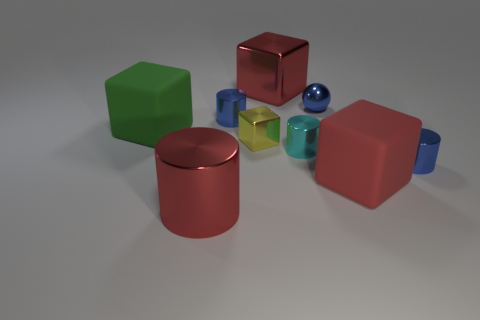The green block is what size?
Give a very brief answer. Large. Is there a large object that is to the left of the large red shiny cylinder that is in front of the tiny blue thing in front of the small cyan cylinder?
Offer a terse response. Yes. What number of metallic objects are behind the yellow thing?
Provide a succinct answer. 3. How many other metal balls are the same color as the sphere?
Keep it short and to the point. 0. What number of objects are either things to the right of the big metallic cylinder or cylinders that are behind the green block?
Give a very brief answer. 7. Are there more tiny cubes than large yellow cylinders?
Make the answer very short. Yes. What is the color of the tiny thing in front of the cyan cylinder?
Ensure brevity in your answer.  Blue. Do the tiny yellow metallic thing and the cyan metallic object have the same shape?
Keep it short and to the point. No. There is a metal thing that is both behind the tiny cyan cylinder and on the right side of the cyan object; what color is it?
Offer a very short reply. Blue. There is a matte object to the right of the cyan thing; is its size the same as the cyan metal cylinder that is on the right side of the red metallic block?
Your response must be concise. No. 